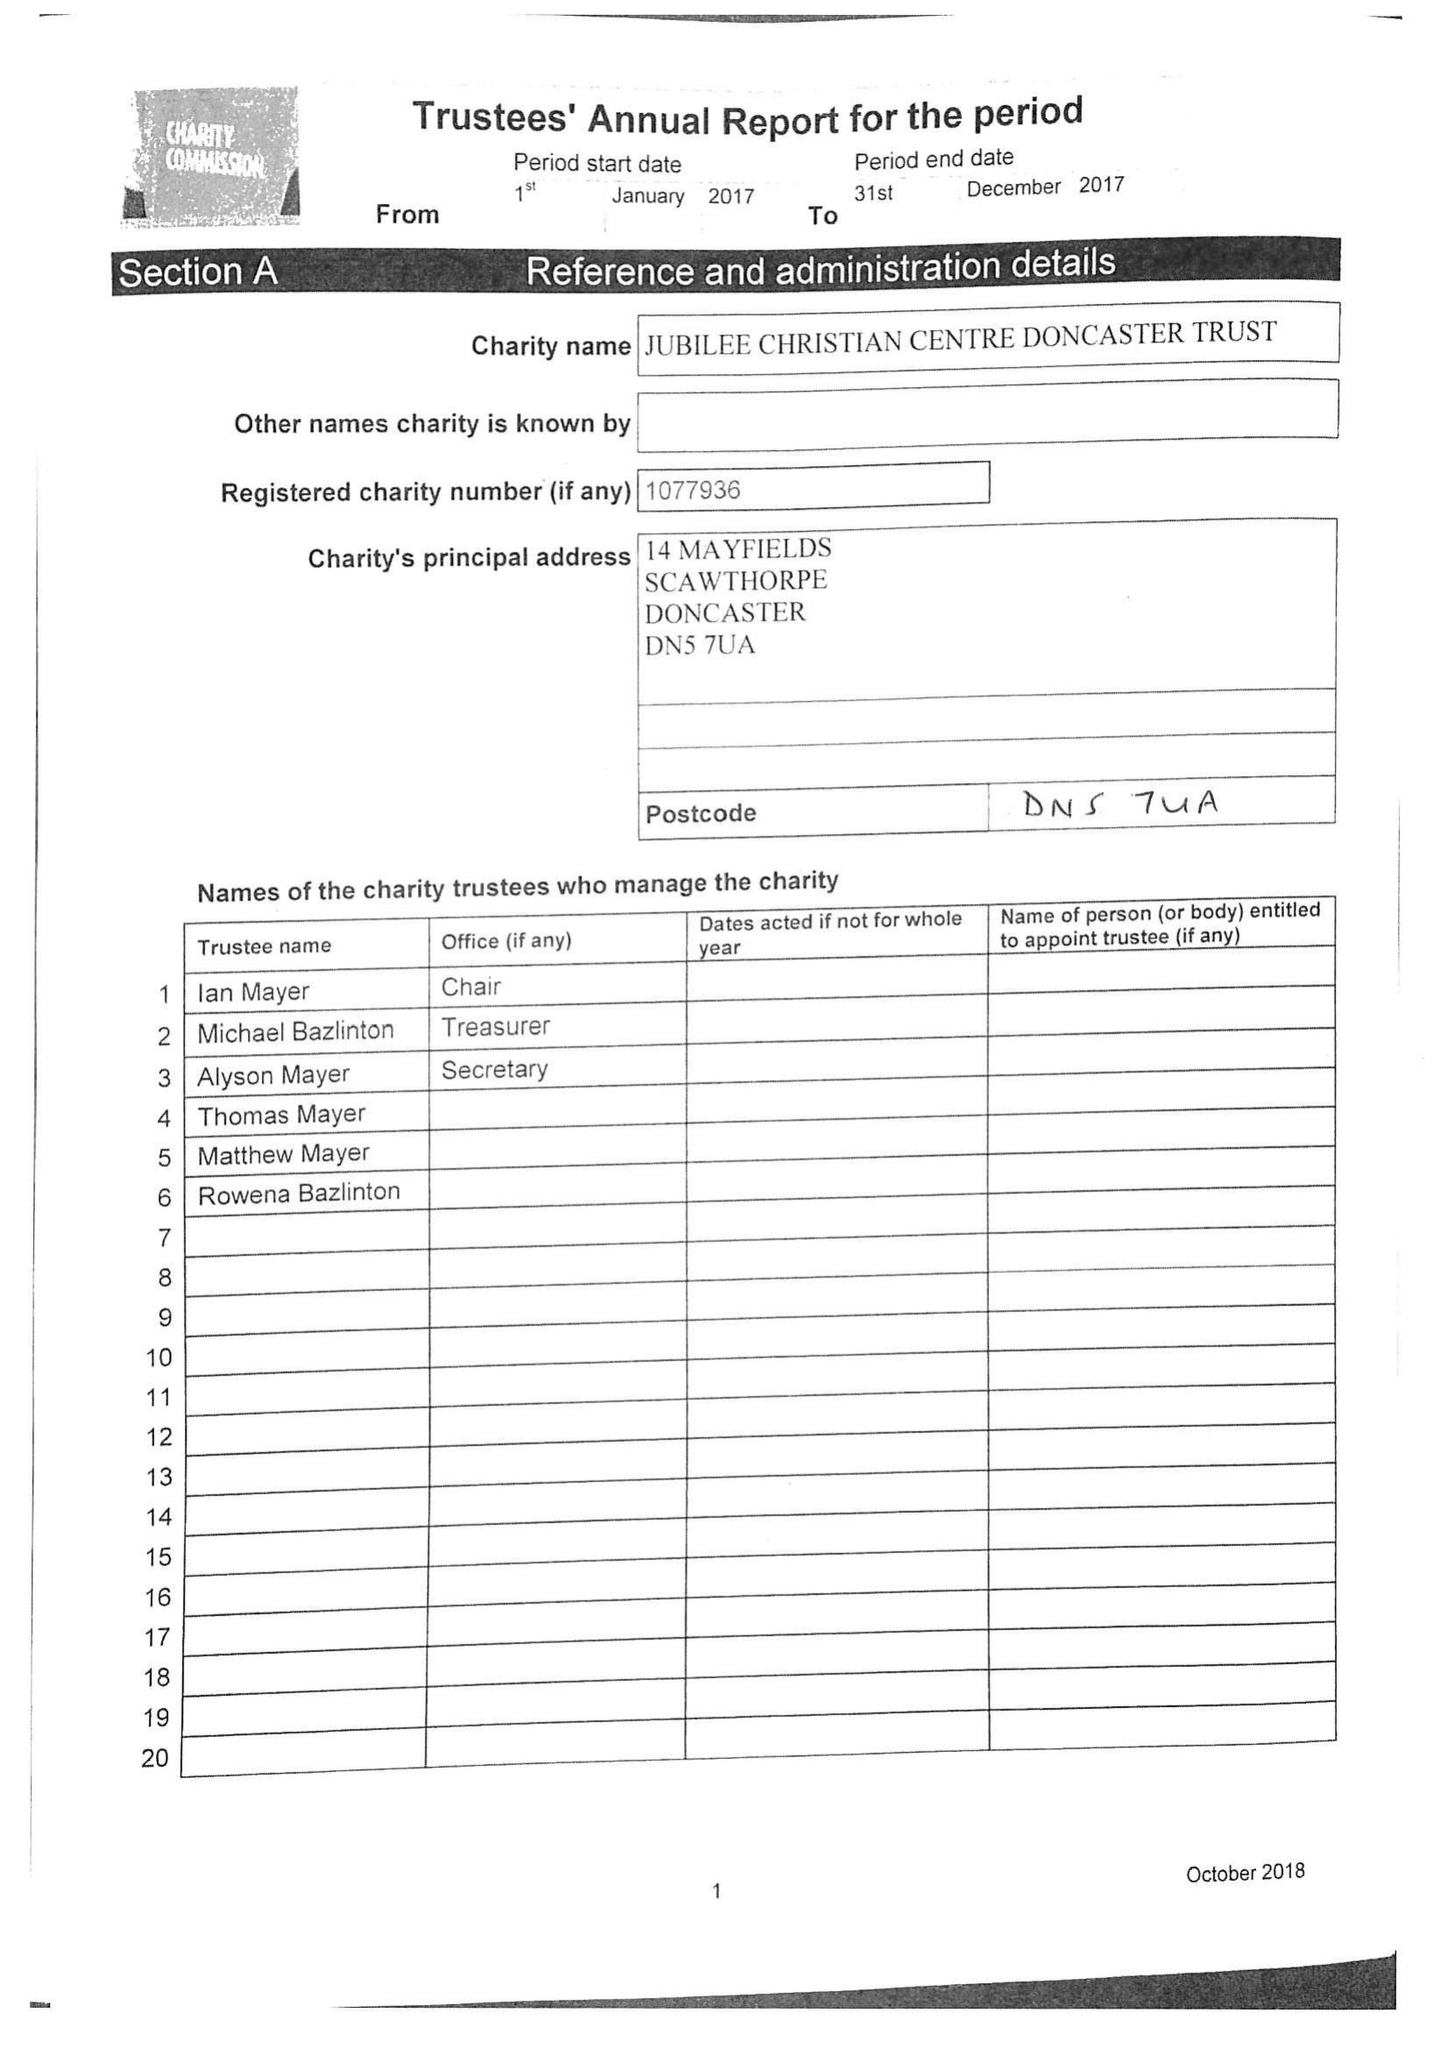What is the value for the spending_annually_in_british_pounds?
Answer the question using a single word or phrase. 12624.00 